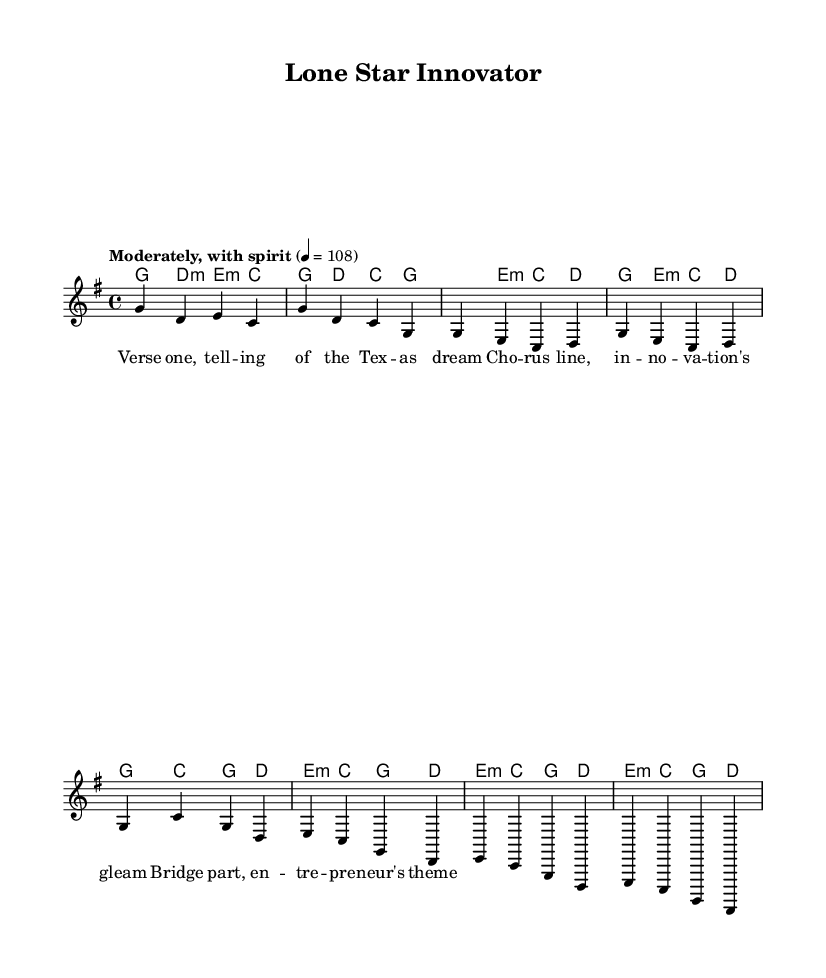What is the key signature of this music? The key signature is indicated at the beginning of the score. In this case, there are no sharps or flats shown, which denotes that the key is G major.
Answer: G major What is the time signature of this music? The time signature, usually displayed at the beginning of the piece, is shown as 4/4, meaning there are four beats in each measure and the quarter note receives one beat.
Answer: 4/4 What is the tempo marking of this music? The tempo marking is located at the beginning of the score, where it indicates that the piece should be played "Moderately, with spirit" at a speed of 108 beats per minute.
Answer: Moderately, with spirit What are the primary chords used in the chorus? The chorus contains the chords that are associated with the melody notes in that section. In this case, the chords are G, C, and D.
Answer: G, C, D How does the bridge differ in structure from the verse? The bridge is typically different in terms of melody and harmony, and here the structure uses different chord progressions and may reflect a shift in the theme, focusing on the entrepreneur's spirit as a contrast to the verse.
Answer: Different chord progressions What is a key theme represented in the lyrics? By looking at the lyrics, the main theme revolves around the Texan dream and innovation, which is a hallmark of folk music celebrating the entrepreneurial spirit.
Answer: Texan dream and innovation What is the significance of the tempo marking in this folk song? The tempo marking "Moderately, with spirit" suggests that the song is meant to be lively and engaging, which is typical in folk music as it encourages participation and reflects an upbeat theme.
Answer: Engaging and lively 